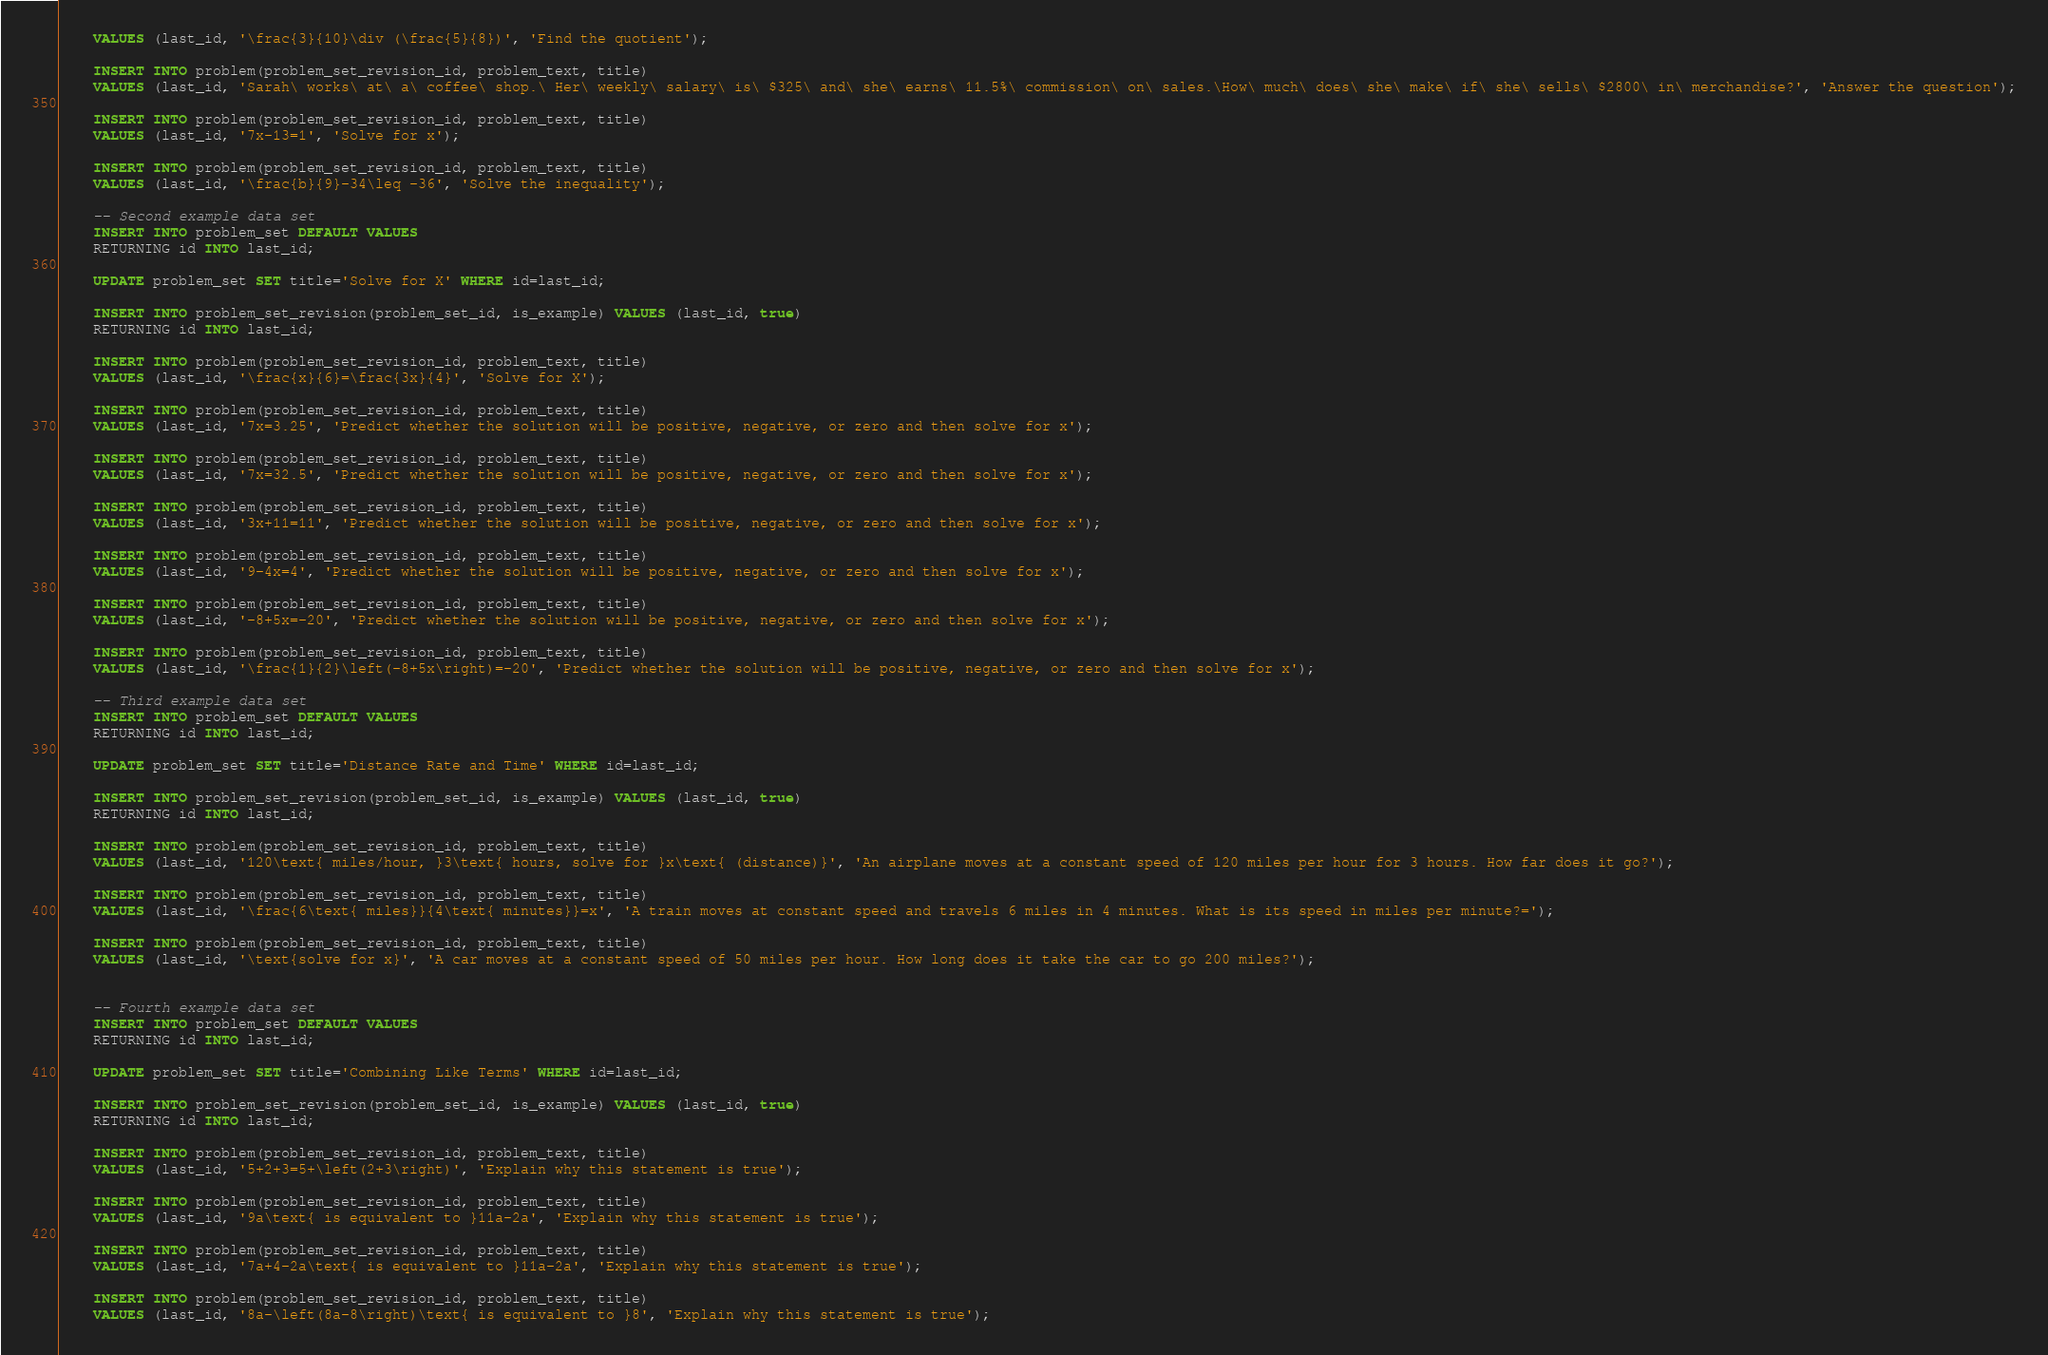Convert code to text. <code><loc_0><loc_0><loc_500><loc_500><_SQL_>    VALUES (last_id, '\frac{3}{10}\div (\frac{5}{8})', 'Find the quotient');

    INSERT INTO problem(problem_set_revision_id, problem_text, title)
    VALUES (last_id, 'Sarah\ works\ at\ a\ coffee\ shop.\ Her\ weekly\ salary\ is\ $325\ and\ she\ earns\ 11.5%\ commission\ on\ sales.\How\ much\ does\ she\ make\ if\ she\ sells\ $2800\ in\ merchandise?', 'Answer the question');

    INSERT INTO problem(problem_set_revision_id, problem_text, title)
    VALUES (last_id, '7x-13=1', 'Solve for x');

    INSERT INTO problem(problem_set_revision_id, problem_text, title)
    VALUES (last_id, '\frac{b}{9}-34\leq -36', 'Solve the inequality');

    -- Second example data set
    INSERT INTO problem_set DEFAULT VALUES
    RETURNING id INTO last_id;

    UPDATE problem_set SET title='Solve for X' WHERE id=last_id;

    INSERT INTO problem_set_revision(problem_set_id, is_example) VALUES (last_id, true)
    RETURNING id INTO last_id;

    INSERT INTO problem(problem_set_revision_id, problem_text, title)
    VALUES (last_id, '\frac{x}{6}=\frac{3x}{4}', 'Solve for X');

    INSERT INTO problem(problem_set_revision_id, problem_text, title)
    VALUES (last_id, '7x=3.25', 'Predict whether the solution will be positive, negative, or zero and then solve for x');

    INSERT INTO problem(problem_set_revision_id, problem_text, title)
    VALUES (last_id, '7x=32.5', 'Predict whether the solution will be positive, negative, or zero and then solve for x');

    INSERT INTO problem(problem_set_revision_id, problem_text, title)
    VALUES (last_id, '3x+11=11', 'Predict whether the solution will be positive, negative, or zero and then solve for x');

    INSERT INTO problem(problem_set_revision_id, problem_text, title)
    VALUES (last_id, '9-4x=4', 'Predict whether the solution will be positive, negative, or zero and then solve for x');

    INSERT INTO problem(problem_set_revision_id, problem_text, title)
    VALUES (last_id, '-8+5x=-20', 'Predict whether the solution will be positive, negative, or zero and then solve for x');

    INSERT INTO problem(problem_set_revision_id, problem_text, title)
    VALUES (last_id, '\frac{1}{2}\left(-8+5x\right)=-20', 'Predict whether the solution will be positive, negative, or zero and then solve for x');

    -- Third example data set
    INSERT INTO problem_set DEFAULT VALUES
    RETURNING id INTO last_id;

    UPDATE problem_set SET title='Distance Rate and Time' WHERE id=last_id;

    INSERT INTO problem_set_revision(problem_set_id, is_example) VALUES (last_id, true)
    RETURNING id INTO last_id;

    INSERT INTO problem(problem_set_revision_id, problem_text, title)
    VALUES (last_id, '120\text{ miles/hour, }3\text{ hours, solve for }x\text{ (distance)}', 'An airplane moves at a constant speed of 120 miles per hour for 3 hours. How far does it go?');

    INSERT INTO problem(problem_set_revision_id, problem_text, title)
    VALUES (last_id, '\frac{6\text{ miles}}{4\text{ minutes}}=x', 'A train moves at constant speed and travels 6 miles in 4 minutes. What is its speed in miles per minute?=');

    INSERT INTO problem(problem_set_revision_id, problem_text, title)
    VALUES (last_id, '\text{solve for x}', 'A car moves at a constant speed of 50 miles per hour. How long does it take the car to go 200 miles?');


    -- Fourth example data set
    INSERT INTO problem_set DEFAULT VALUES
    RETURNING id INTO last_id;

    UPDATE problem_set SET title='Combining Like Terms' WHERE id=last_id;

    INSERT INTO problem_set_revision(problem_set_id, is_example) VALUES (last_id, true)
    RETURNING id INTO last_id;

    INSERT INTO problem(problem_set_revision_id, problem_text, title)
    VALUES (last_id, '5+2+3=5+\left(2+3\right)', 'Explain why this statement is true');

    INSERT INTO problem(problem_set_revision_id, problem_text, title)
    VALUES (last_id, '9a\text{ is equivalent to }11a-2a', 'Explain why this statement is true');

    INSERT INTO problem(problem_set_revision_id, problem_text, title)
    VALUES (last_id, '7a+4-2a\text{ is equivalent to }11a-2a', 'Explain why this statement is true');

    INSERT INTO problem(problem_set_revision_id, problem_text, title)
    VALUES (last_id, '8a-\left(8a-8\right)\text{ is equivalent to }8', 'Explain why this statement is true');
</code> 